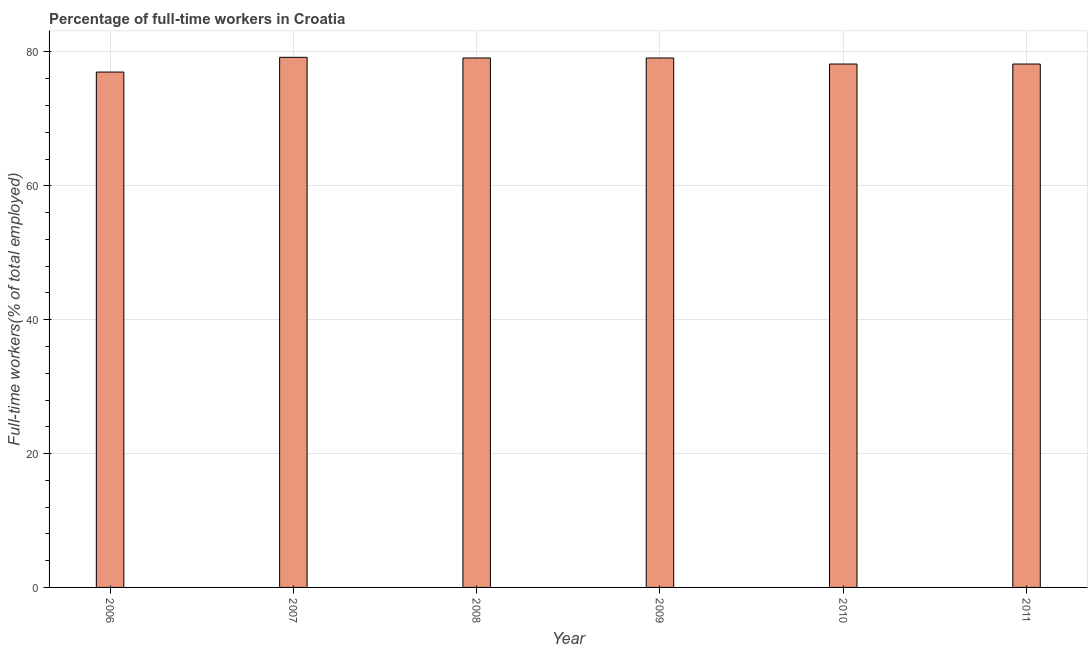Does the graph contain grids?
Offer a terse response. Yes. What is the title of the graph?
Provide a succinct answer. Percentage of full-time workers in Croatia. What is the label or title of the Y-axis?
Give a very brief answer. Full-time workers(% of total employed). What is the percentage of full-time workers in 2009?
Offer a terse response. 79.1. Across all years, what is the maximum percentage of full-time workers?
Your answer should be compact. 79.2. In which year was the percentage of full-time workers minimum?
Your answer should be compact. 2006. What is the sum of the percentage of full-time workers?
Your response must be concise. 470.8. What is the average percentage of full-time workers per year?
Offer a terse response. 78.47. What is the median percentage of full-time workers?
Your answer should be very brief. 78.65. What is the difference between the highest and the second highest percentage of full-time workers?
Keep it short and to the point. 0.1. How many bars are there?
Ensure brevity in your answer.  6. Are all the bars in the graph horizontal?
Provide a short and direct response. No. How many years are there in the graph?
Provide a short and direct response. 6. What is the difference between two consecutive major ticks on the Y-axis?
Provide a succinct answer. 20. Are the values on the major ticks of Y-axis written in scientific E-notation?
Your response must be concise. No. What is the Full-time workers(% of total employed) in 2006?
Your answer should be compact. 77. What is the Full-time workers(% of total employed) of 2007?
Ensure brevity in your answer.  79.2. What is the Full-time workers(% of total employed) in 2008?
Give a very brief answer. 79.1. What is the Full-time workers(% of total employed) in 2009?
Your response must be concise. 79.1. What is the Full-time workers(% of total employed) of 2010?
Ensure brevity in your answer.  78.2. What is the Full-time workers(% of total employed) in 2011?
Offer a terse response. 78.2. What is the difference between the Full-time workers(% of total employed) in 2007 and 2008?
Your answer should be very brief. 0.1. What is the difference between the Full-time workers(% of total employed) in 2008 and 2009?
Offer a very short reply. 0. What is the difference between the Full-time workers(% of total employed) in 2009 and 2010?
Make the answer very short. 0.9. What is the difference between the Full-time workers(% of total employed) in 2009 and 2011?
Keep it short and to the point. 0.9. What is the difference between the Full-time workers(% of total employed) in 2010 and 2011?
Ensure brevity in your answer.  0. What is the ratio of the Full-time workers(% of total employed) in 2006 to that in 2008?
Give a very brief answer. 0.97. What is the ratio of the Full-time workers(% of total employed) in 2006 to that in 2010?
Provide a succinct answer. 0.98. What is the ratio of the Full-time workers(% of total employed) in 2006 to that in 2011?
Keep it short and to the point. 0.98. What is the ratio of the Full-time workers(% of total employed) in 2008 to that in 2011?
Offer a very short reply. 1.01. 